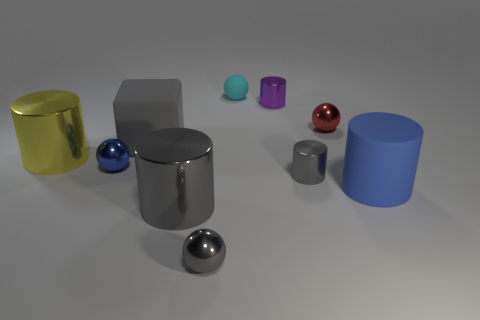What is the size of the ball that is the same color as the cube?
Make the answer very short. Small. There is a ball that is right of the ball that is behind the purple cylinder; what is its material?
Keep it short and to the point. Metal. What number of metal things are either large gray cylinders or tiny spheres?
Provide a succinct answer. 4. The other matte object that is the same shape as the small purple object is what color?
Your answer should be very brief. Blue. How many big metal cylinders have the same color as the small rubber ball?
Your answer should be compact. 0. Is there a tiny blue ball that is right of the object right of the tiny red thing?
Offer a terse response. No. How many tiny spheres are both right of the tiny gray ball and in front of the rubber ball?
Offer a terse response. 1. How many red spheres are made of the same material as the big yellow object?
Give a very brief answer. 1. What size is the gray shiny cylinder behind the big rubber thing right of the red sphere?
Ensure brevity in your answer.  Small. Is there a blue rubber object of the same shape as the tiny red shiny object?
Provide a short and direct response. No. 